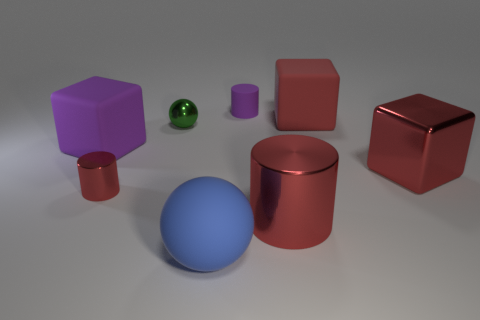There is a sphere in front of the tiny red cylinder; what color is it?
Your answer should be very brief. Blue. How many things are either big objects that are in front of the green metallic ball or green shiny things?
Your answer should be compact. 5. What is the color of the cylinder that is the same size as the blue rubber thing?
Make the answer very short. Red. Are there more things left of the large red cylinder than big shiny things?
Offer a very short reply. Yes. There is a object that is to the left of the small green shiny sphere and on the right side of the big purple block; what is its material?
Your answer should be very brief. Metal. Is the color of the small cylinder on the left side of the tiny purple thing the same as the shiny cylinder to the right of the tiny purple rubber cylinder?
Offer a terse response. Yes. How many other objects are the same size as the purple block?
Offer a very short reply. 4. There is a purple thing behind the big thing to the left of the large blue thing; are there any small cylinders that are to the right of it?
Offer a very short reply. No. Is the material of the red cylinder to the left of the purple cylinder the same as the blue ball?
Your answer should be very brief. No. What is the color of the other shiny object that is the same shape as the tiny red object?
Provide a succinct answer. Red. 